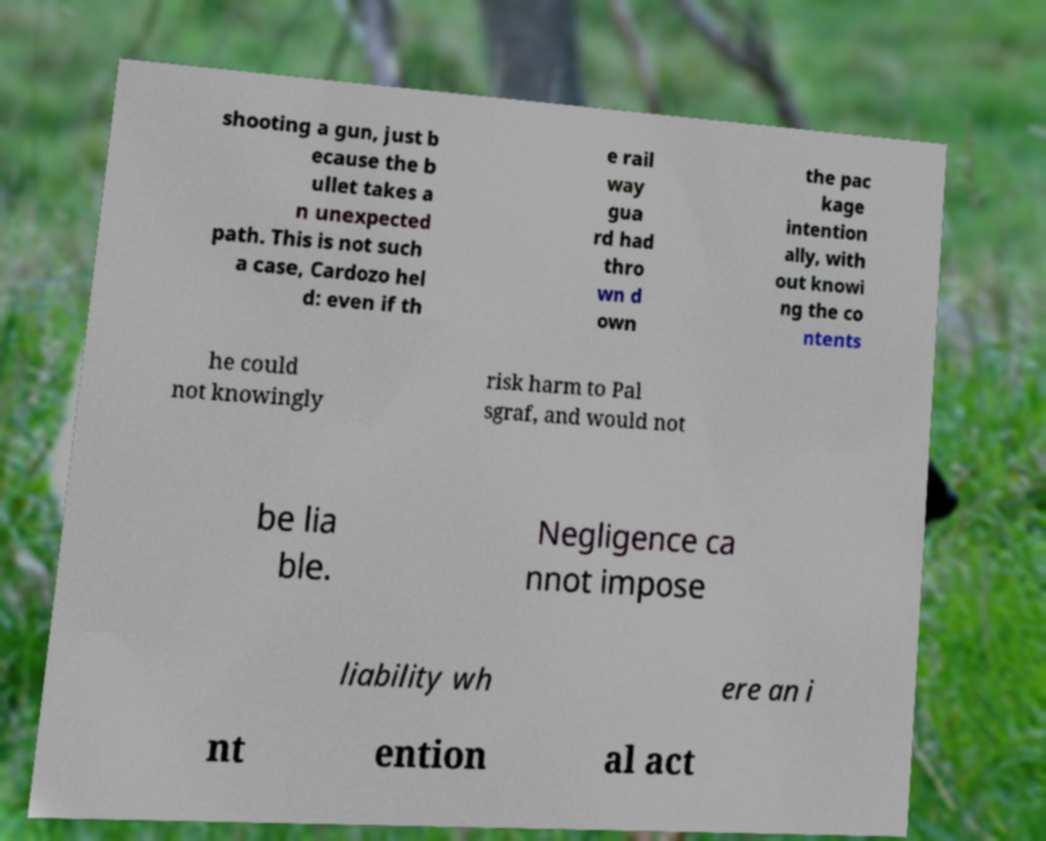For documentation purposes, I need the text within this image transcribed. Could you provide that? shooting a gun, just b ecause the b ullet takes a n unexpected path. This is not such a case, Cardozo hel d: even if th e rail way gua rd had thro wn d own the pac kage intention ally, with out knowi ng the co ntents he could not knowingly risk harm to Pal sgraf, and would not be lia ble. Negligence ca nnot impose liability wh ere an i nt ention al act 